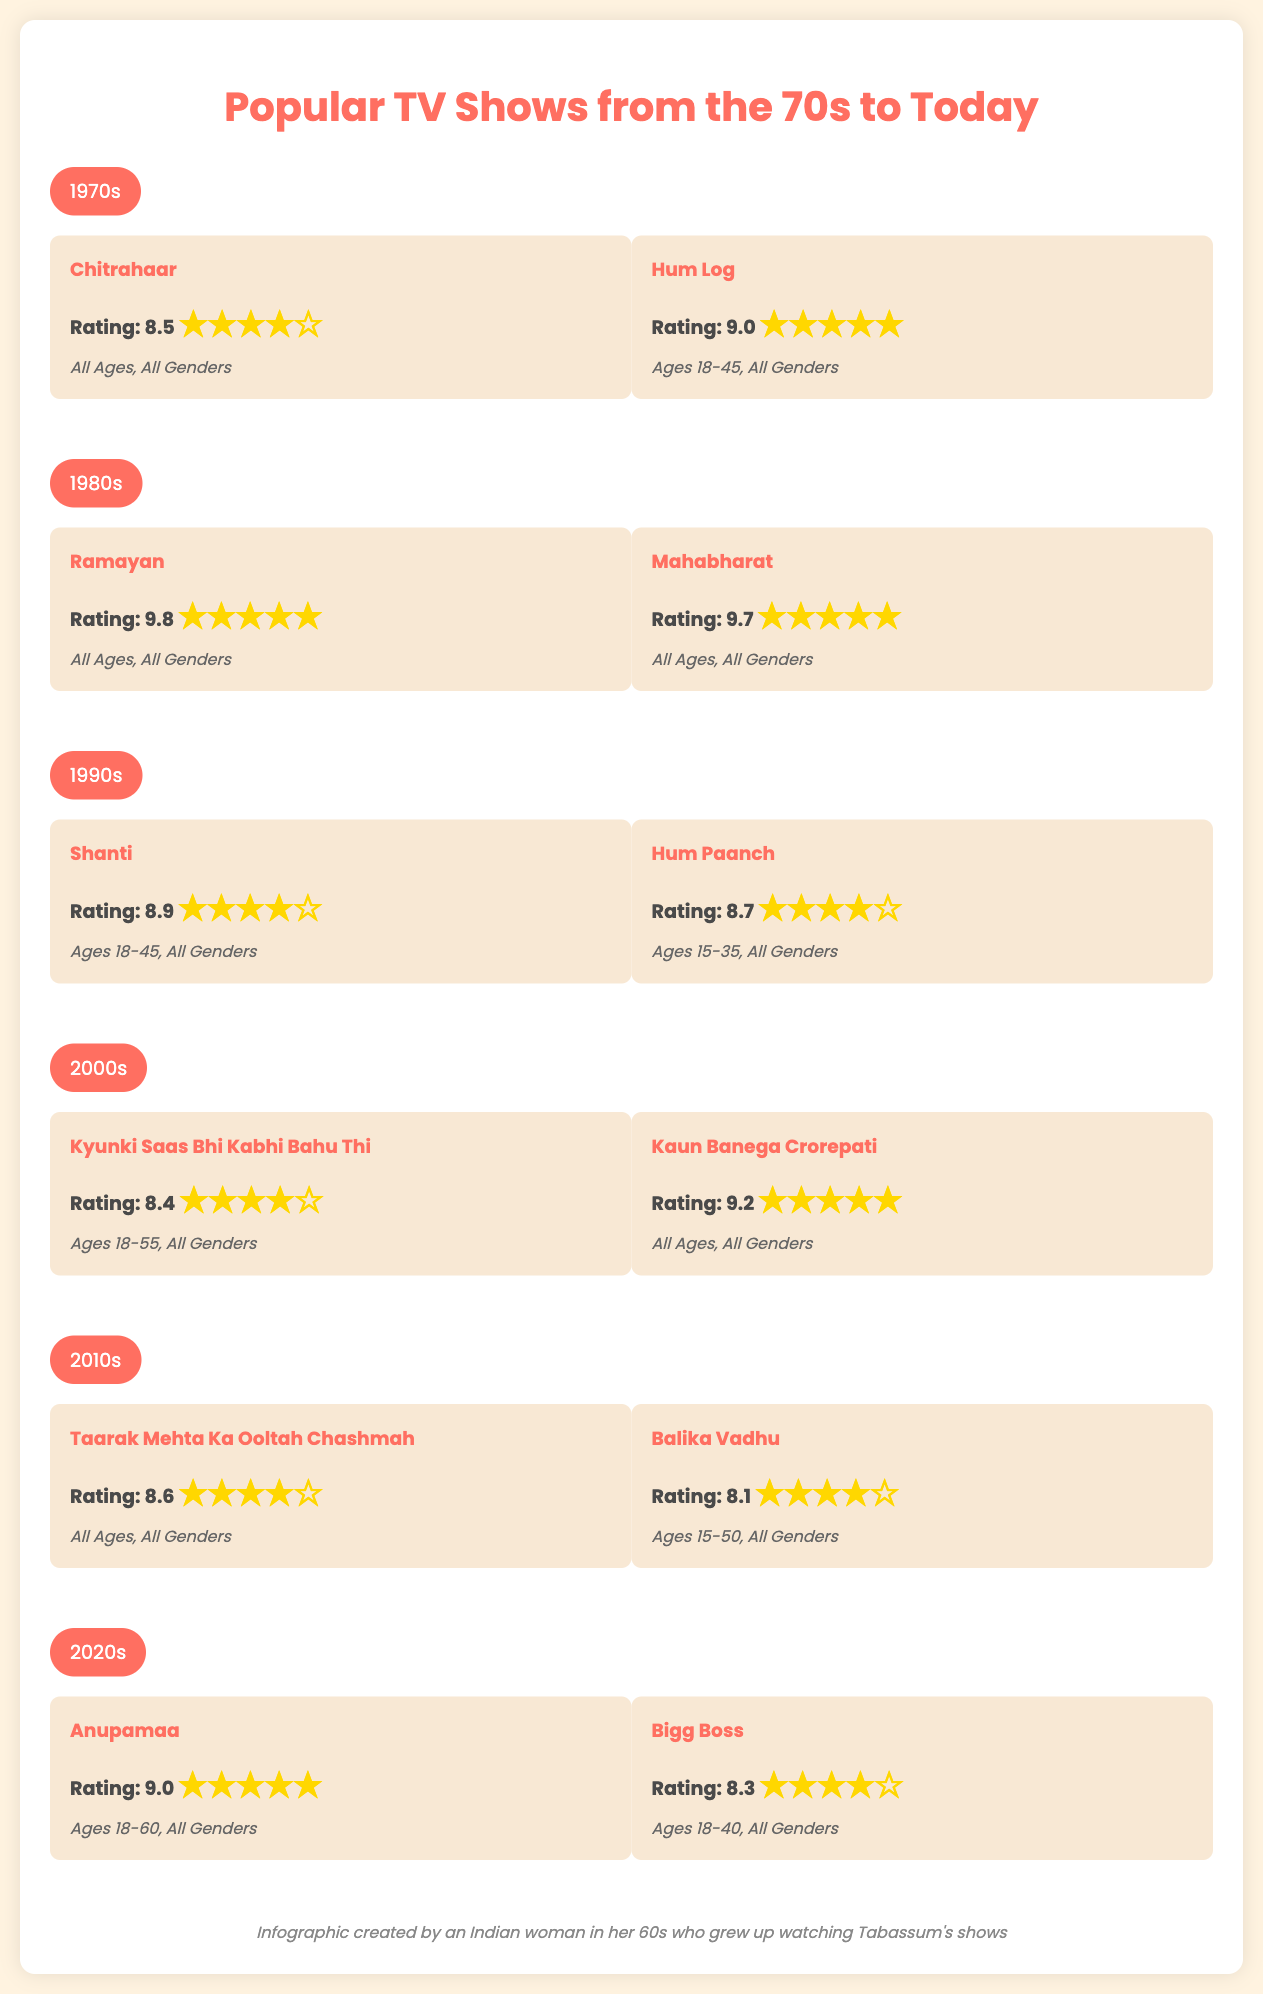what show had the highest rating in the 1980s? The show with the highest rating in the 1980s is "Ramayan," which has a rating of 9.8.
Answer: Ramayan which decade features the show "Kyunki Saas Bhi Kabhi Bahu Thi"? "Kyunki Saas Bhi Kabhi Bahu Thi" is featured in the 2000s decade, according to the document.
Answer: 2000s what is the rating of "Shanti"? The rating of "Shanti" is 8.9, as mentioned in the document.
Answer: 8.9 which demographic is targeted by "Anupamaa"? "Anupamaa" targets viewers aged 18-60, as stated in its demographics.
Answer: Ages 18-60 what is the average rating of the shows from the 1990s? The average rating of the shows from the 1990s, "Shanti" and "Hum Paanch," is calculated as (8.9 + 8.7) / 2 = 8.8.
Answer: 8.8 which show aired in the 2010s with a rating lower than 8.5? "Balika Vadhu" aired in the 2010s with a rating of 8.1, which is lower than 8.5.
Answer: Balika Vadhu how many shows are mentioned from the 70s? The document lists two shows from the 70s: "Chitrahaar" and "Hum Log."
Answer: 2 what demographic does "Kaun Banega Crorepati" cater to? "Kaun Banega Crorepati" caters to "All Ages, All Genders," as stated in the demographics section.
Answer: All Ages, All Genders which show is rated 8.4 in the 2000s? The show rated 8.4 in the 2000s is "Kyunki Saas Bhi Kabhi Bahu Thi."
Answer: Kyunki Saas Bhi Kabhi Bahu Thi 